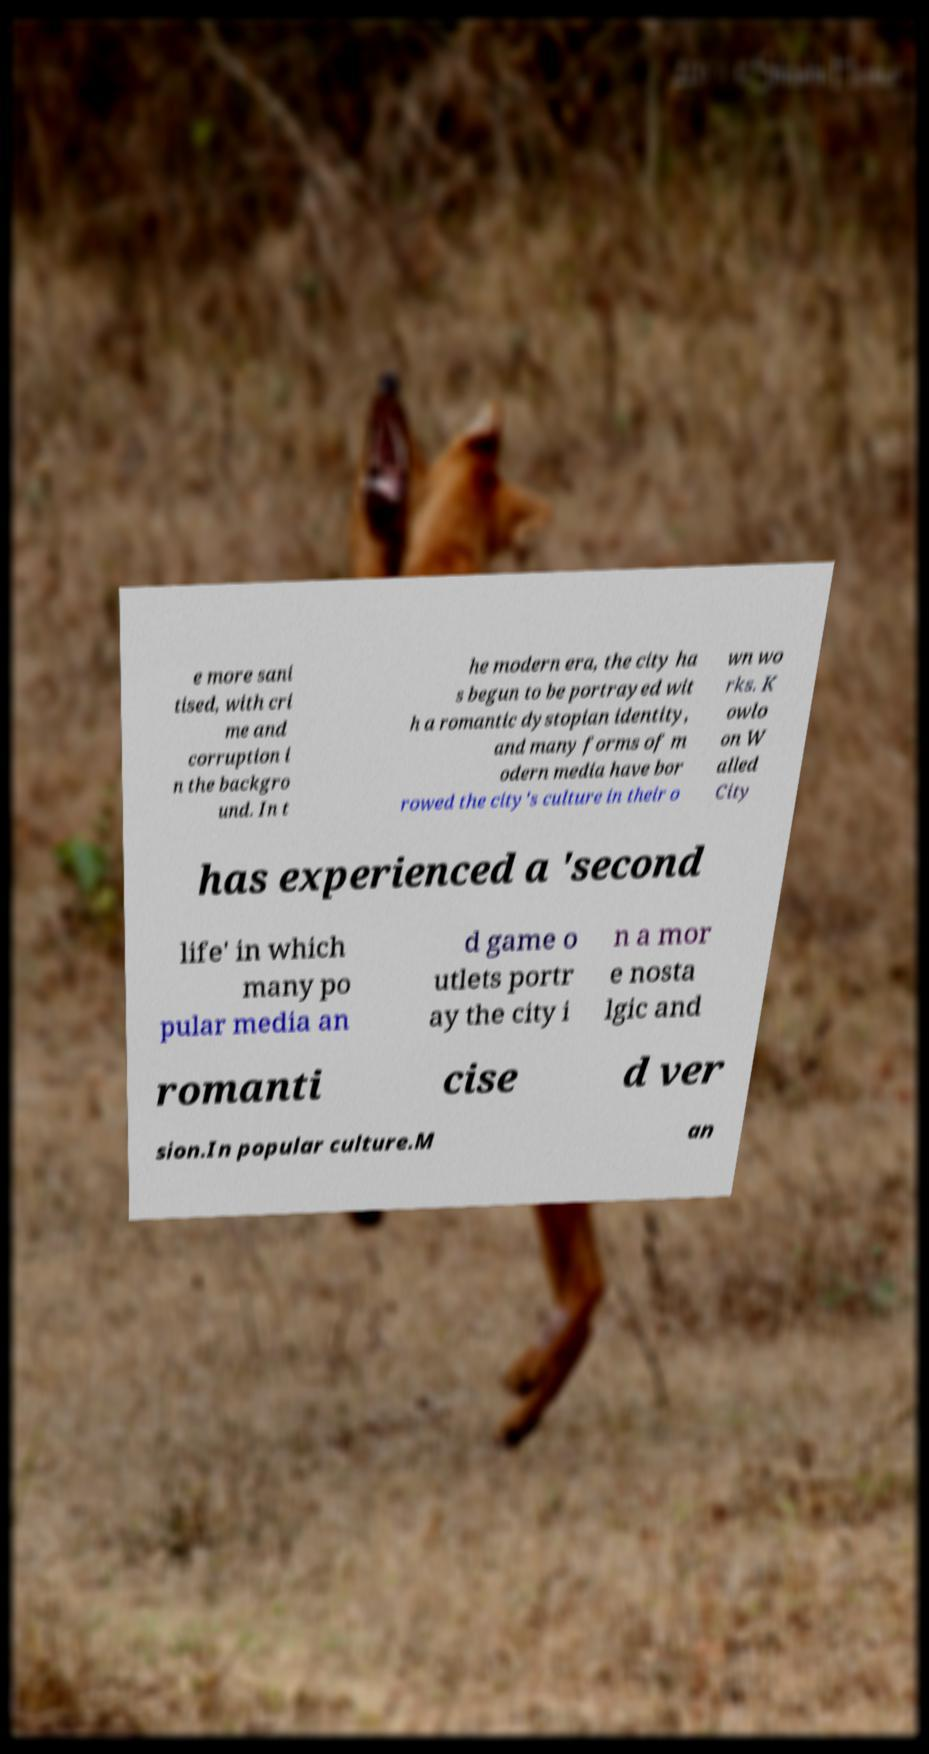Can you read and provide the text displayed in the image?This photo seems to have some interesting text. Can you extract and type it out for me? e more sani tised, with cri me and corruption i n the backgro und. In t he modern era, the city ha s begun to be portrayed wit h a romantic dystopian identity, and many forms of m odern media have bor rowed the city's culture in their o wn wo rks. K owlo on W alled City has experienced a 'second life' in which many po pular media an d game o utlets portr ay the city i n a mor e nosta lgic and romanti cise d ver sion.In popular culture.M an 